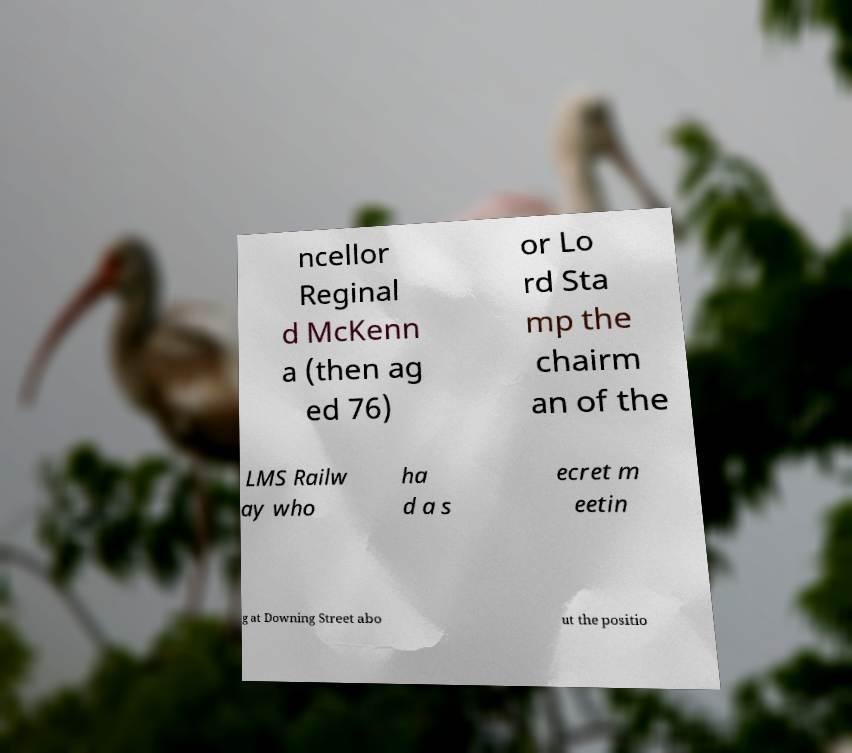Could you assist in decoding the text presented in this image and type it out clearly? ncellor Reginal d McKenn a (then ag ed 76) or Lo rd Sta mp the chairm an of the LMS Railw ay who ha d a s ecret m eetin g at Downing Street abo ut the positio 